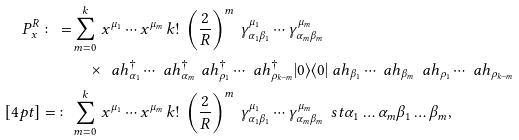<formula> <loc_0><loc_0><loc_500><loc_500>P ^ { R } _ { x } \colon = & \sum _ { m = 0 } ^ { k } \, x ^ { \mu _ { 1 } } \cdots x ^ { \mu _ { m } } \, k ! \, \left ( \frac { 2 } { R } \right ) ^ { m } \, \gamma ^ { \mu _ { 1 } } _ { \alpha _ { 1 } \beta _ { 1 } } \cdots \gamma ^ { \mu _ { m } } _ { \alpha _ { m } \beta _ { m } } \\ & \quad \times \, \ a h ^ { \dagger } _ { \alpha _ { 1 } } \cdots \ a h ^ { \dagger } _ { \alpha _ { m } } \, \ a h ^ { \dagger } _ { \rho _ { 1 } } \cdots \ a h ^ { \dagger } _ { \rho _ { k - m } } | 0 \rangle \langle 0 | \ a h _ { \beta _ { 1 } } \cdots \ a h _ { \beta _ { m } } \, \ a h _ { \rho _ { 1 } } \cdots \ a h _ { \rho _ { k - m } } \\ [ 4 p t ] = \colon & \sum _ { m = 0 } ^ { k } \, x ^ { \mu _ { 1 } } \cdots x ^ { \mu _ { m } } \, k ! \, \left ( \frac { 2 } { R } \right ) ^ { m } \, \gamma ^ { \mu _ { 1 } } _ { \alpha _ { 1 } \beta _ { 1 } } \cdots \gamma ^ { \mu _ { m } } _ { \alpha _ { m } \beta _ { m } } \, \ s t { { \alpha _ { 1 } } \dots { \alpha _ { m } } } { { \beta _ { 1 } } \dots { \beta _ { m } } } ,</formula> 